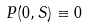<formula> <loc_0><loc_0><loc_500><loc_500>P ( 0 , S ) \equiv 0</formula> 